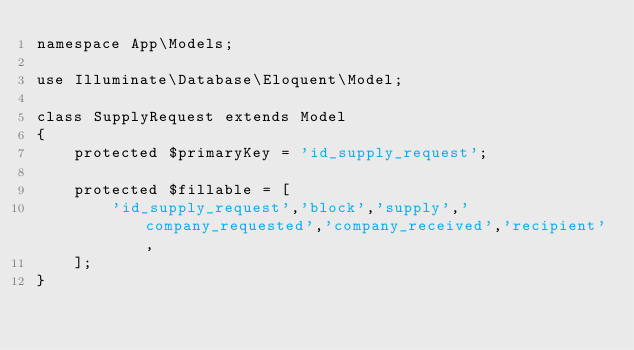<code> <loc_0><loc_0><loc_500><loc_500><_PHP_>namespace App\Models;

use Illuminate\Database\Eloquent\Model;

class SupplyRequest extends Model
{
    protected $primaryKey = 'id_supply_request';

    protected $fillable = [
        'id_supply_request','block','supply','company_requested','company_received','recipient',
    ];
}
</code> 